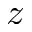<formula> <loc_0><loc_0><loc_500><loc_500>z</formula> 